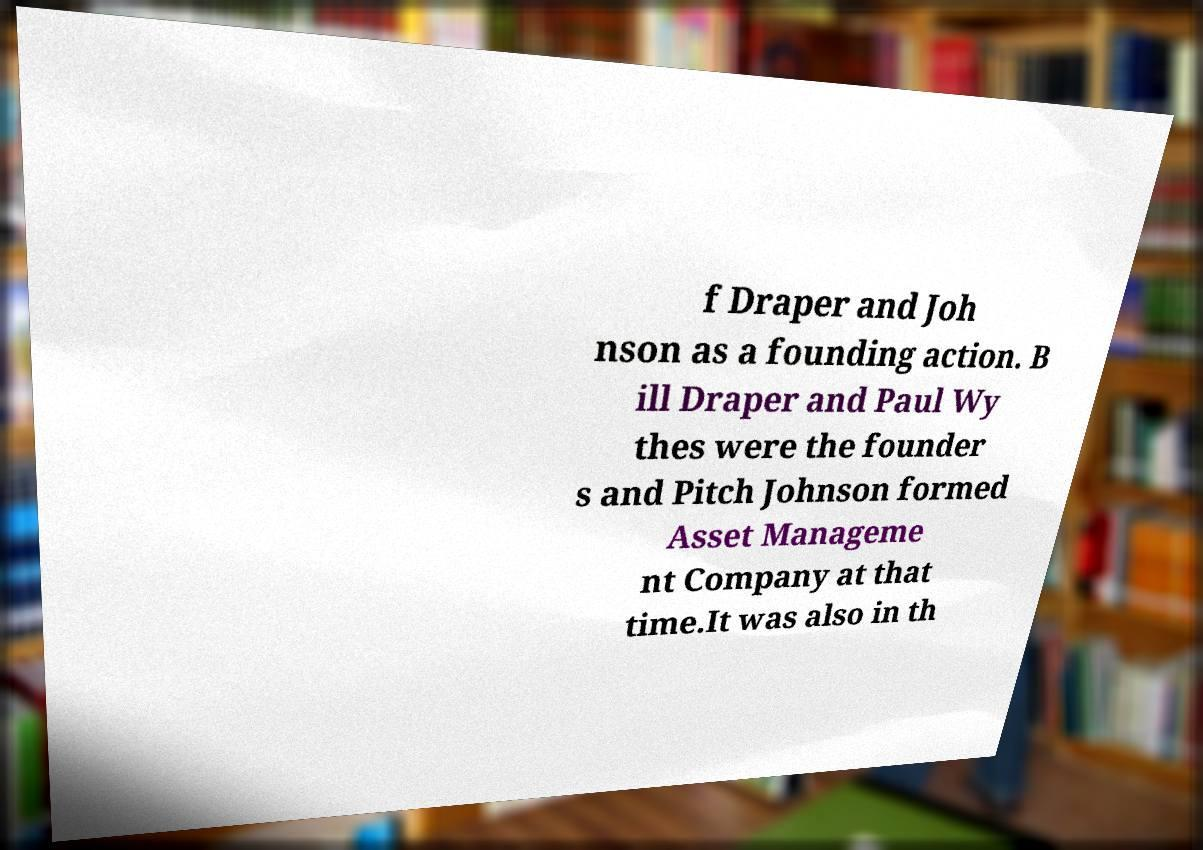What messages or text are displayed in this image? I need them in a readable, typed format. f Draper and Joh nson as a founding action. B ill Draper and Paul Wy thes were the founder s and Pitch Johnson formed Asset Manageme nt Company at that time.It was also in th 